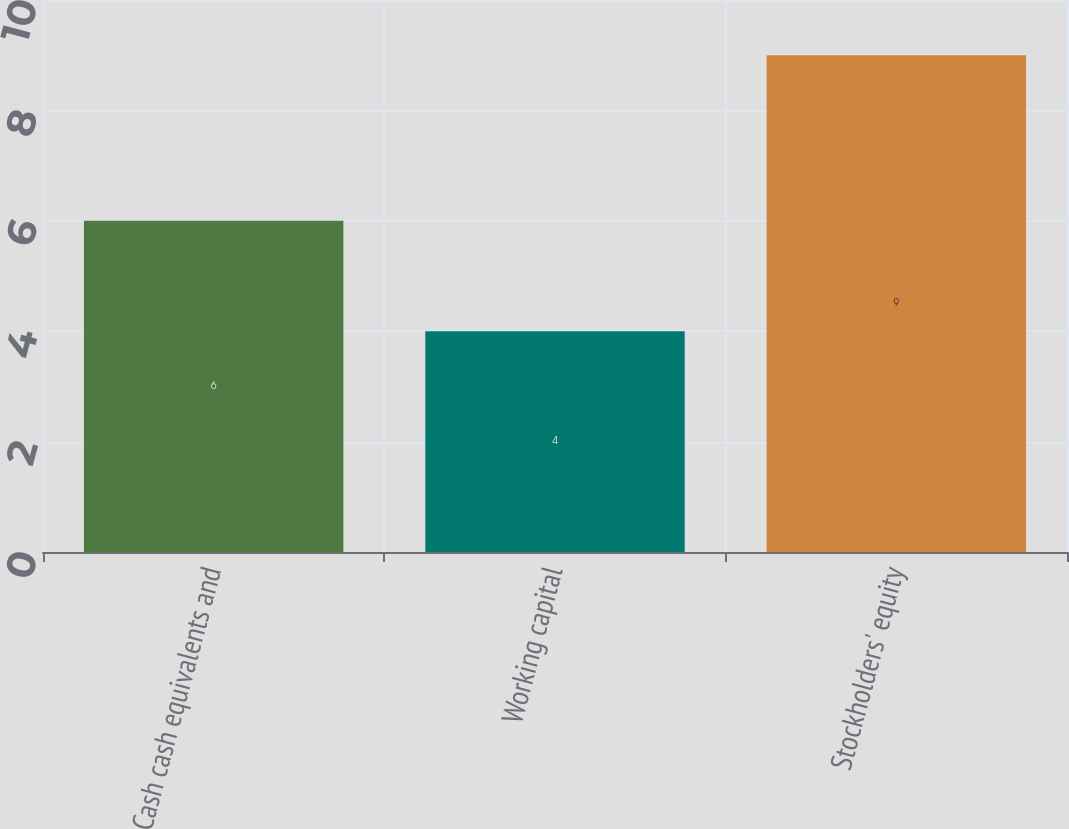<chart> <loc_0><loc_0><loc_500><loc_500><bar_chart><fcel>Cash cash equivalents and<fcel>Working capital<fcel>Stockholders' equity<nl><fcel>6<fcel>4<fcel>9<nl></chart> 